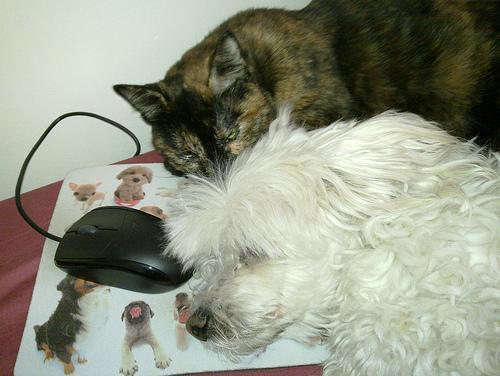How many live animals are there?
Give a very brief answer. 2. 